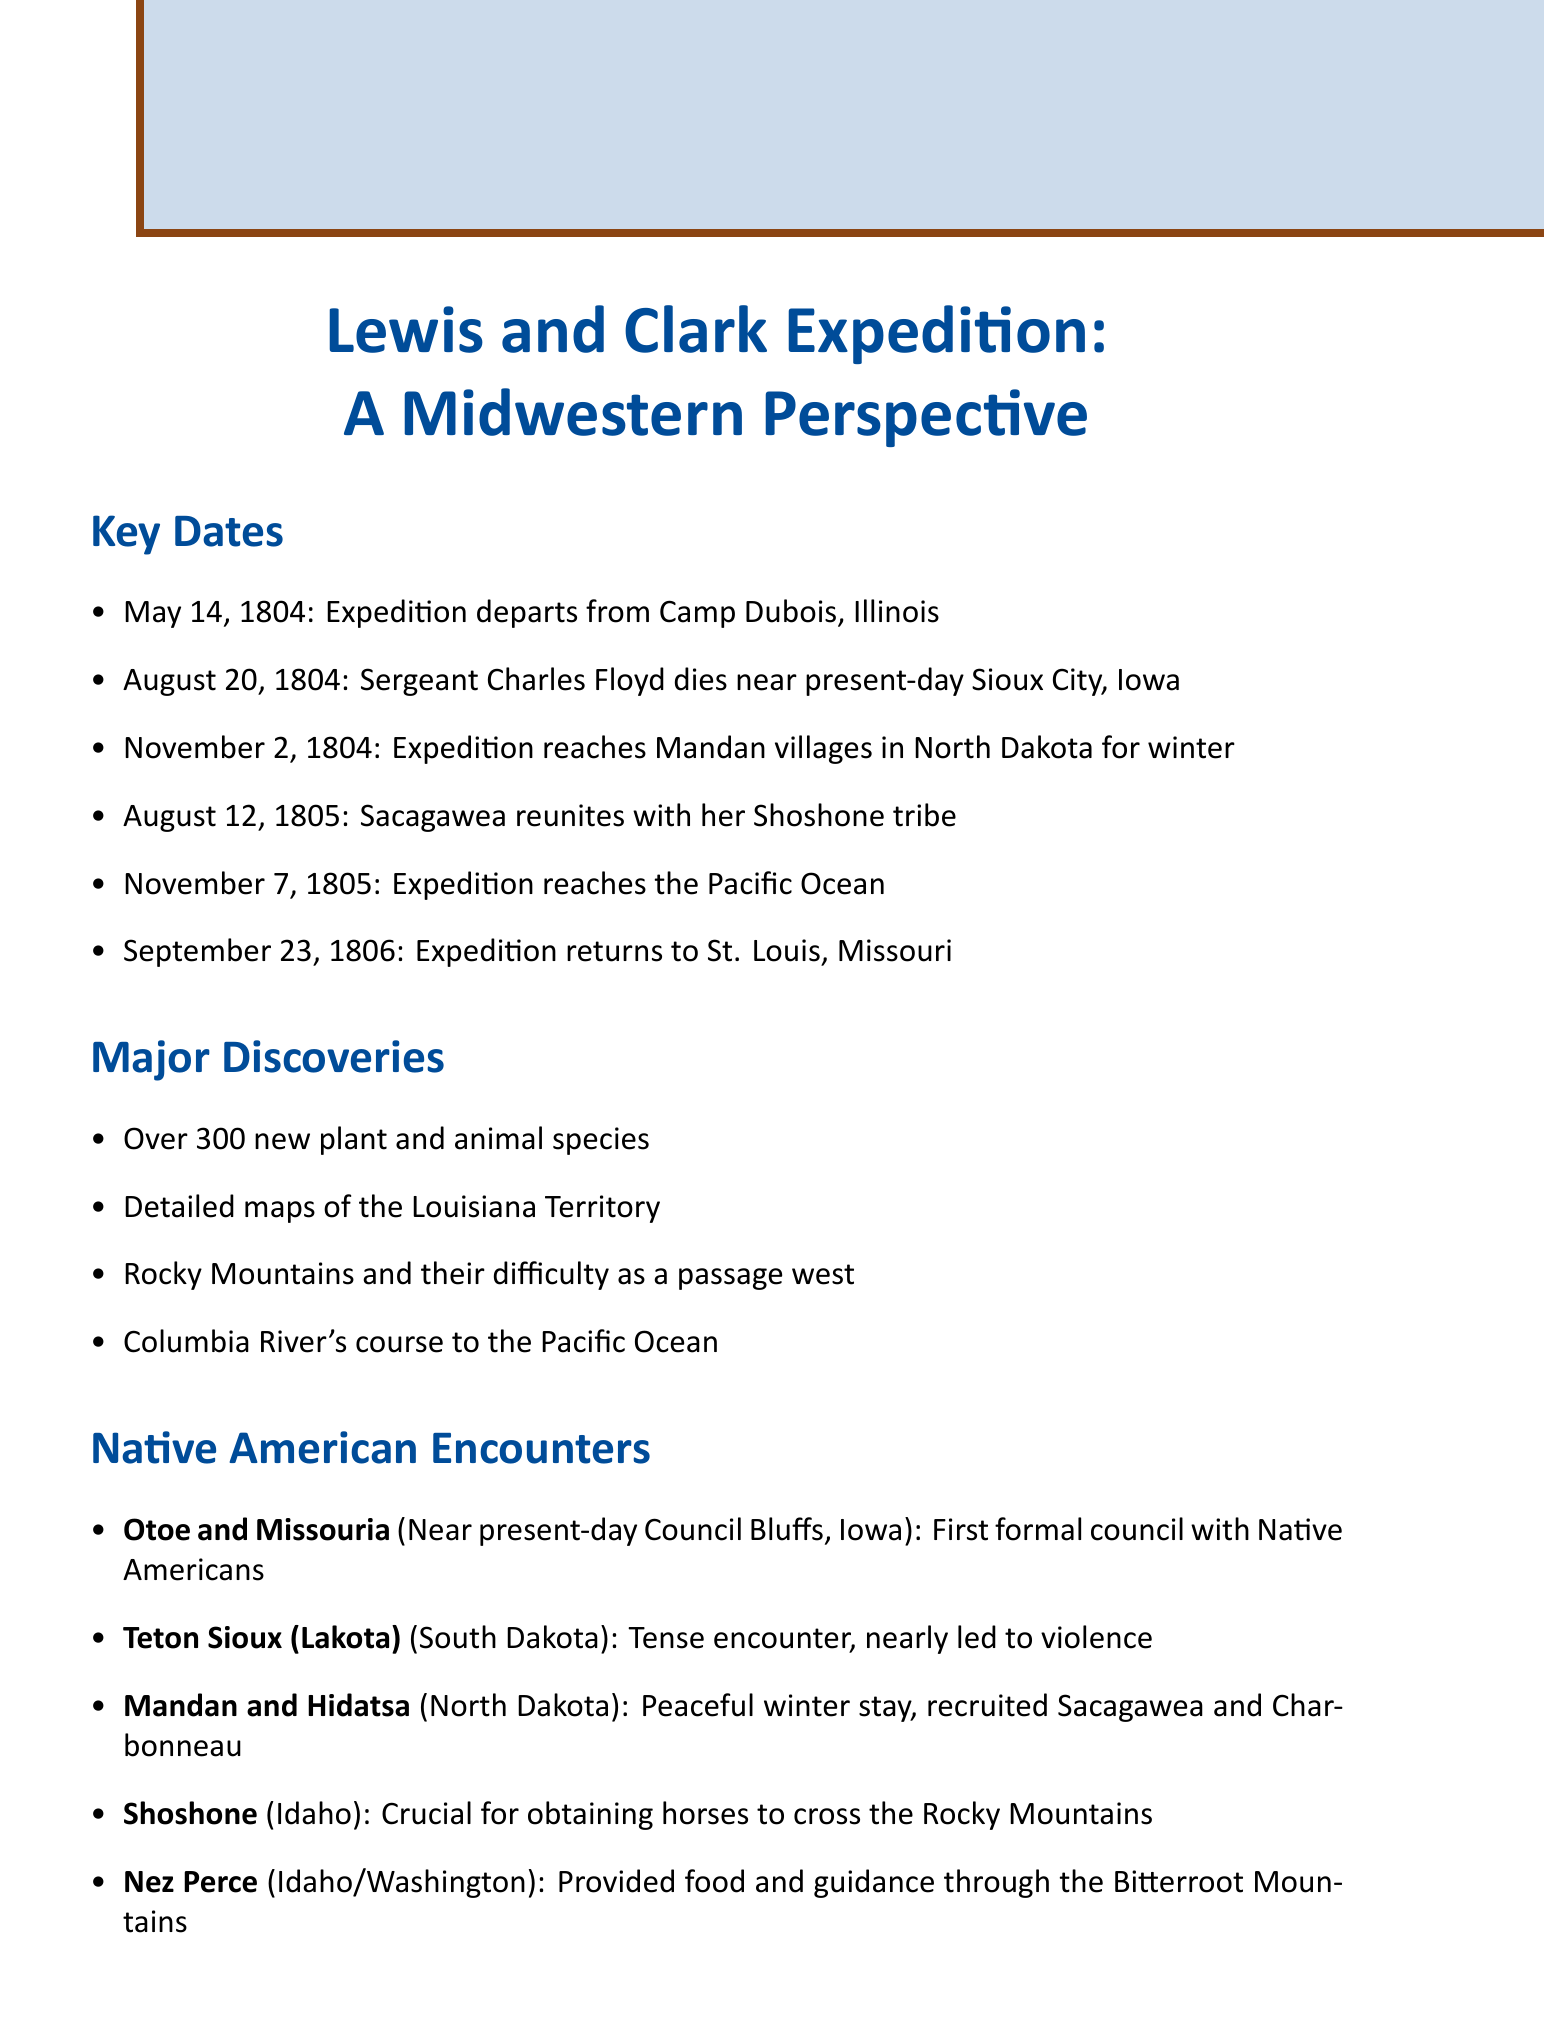What date did the expedition depart? The document states that the expedition departed on May 14, 1804.
Answer: May 14, 1804 Who died on August 20, 1804? The document mentions that Sergeant Charles Floyd died on this date.
Answer: Sergeant Charles Floyd Where did the expedition spend the winter of 1804? The document indicates that the expedition reached the Mandan villages in North Dakota for winter.
Answer: Mandan villages, North Dakota What crucial resource did the Shoshone provide? According to the document, the Shoshone provided horses necessary for crossing the Rocky Mountains.
Answer: Horses What geographical feature did the expedition reach on November 7, 1805? The document states that the expedition reached the Pacific Ocean on this date.
Answer: Pacific Ocean Which Native American tribe had a tense encounter with the expedition? The document notes that the Teton Sioux (Lakota) had a tense encounter, nearly leading to violence.
Answer: Teton Sioux (Lakota) What major discovery involved the Columbia River? The expedition mapped the Columbia River's course to the Pacific Ocean, as stated in the document.
Answer: Columbia River's course to the Pacific Ocean Which location served as both the start and end point of the expedition? The document clarifies that St. Louis, Missouri, served as the starting and ending point of the expedition.
Answer: St. Louis, Missouri How many new species were documented during the expedition? The document indicates that the expedition discovered over 300 new plant and animal species.
Answer: Over 300 